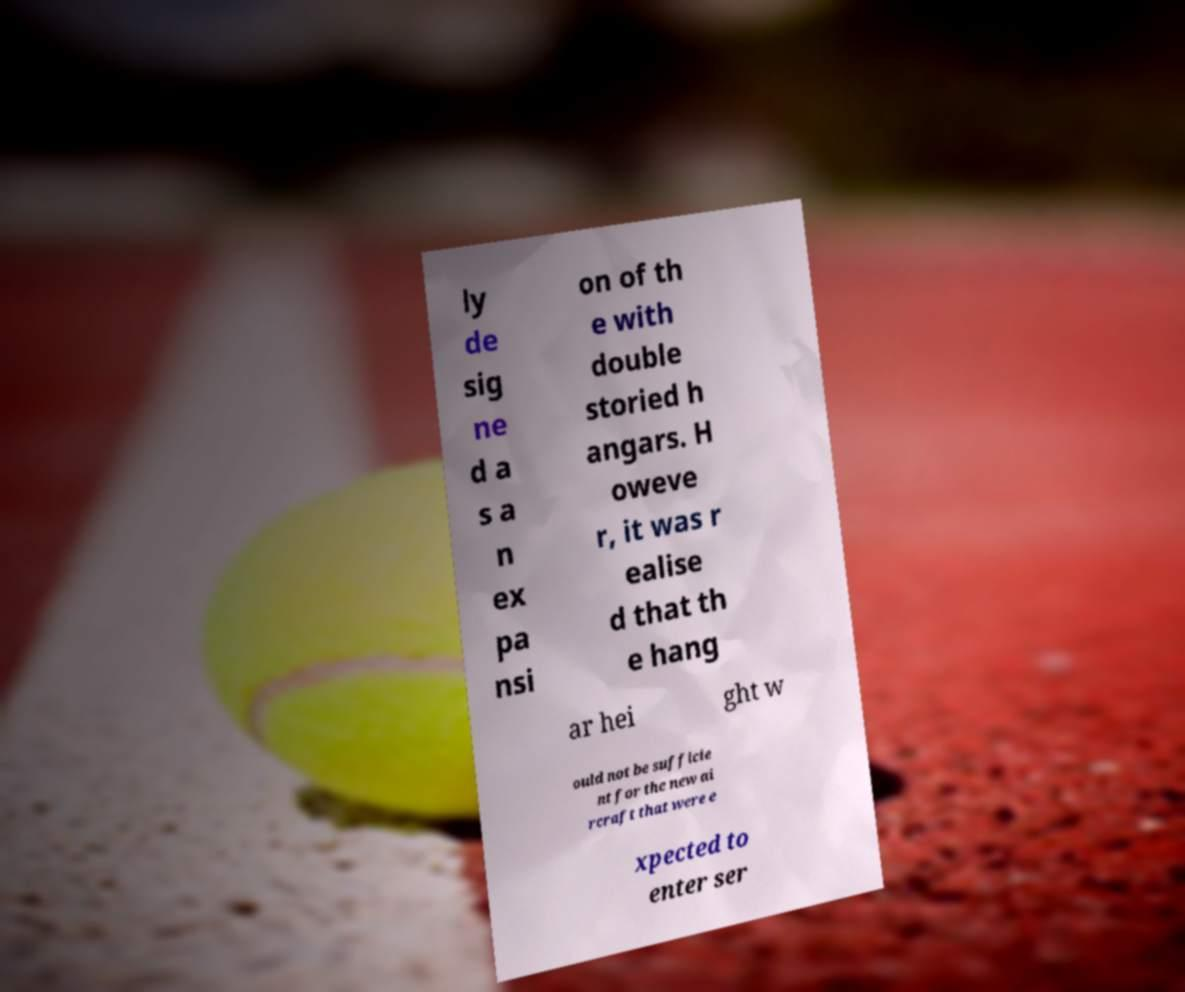I need the written content from this picture converted into text. Can you do that? ly de sig ne d a s a n ex pa nsi on of th e with double storied h angars. H oweve r, it was r ealise d that th e hang ar hei ght w ould not be sufficie nt for the new ai rcraft that were e xpected to enter ser 